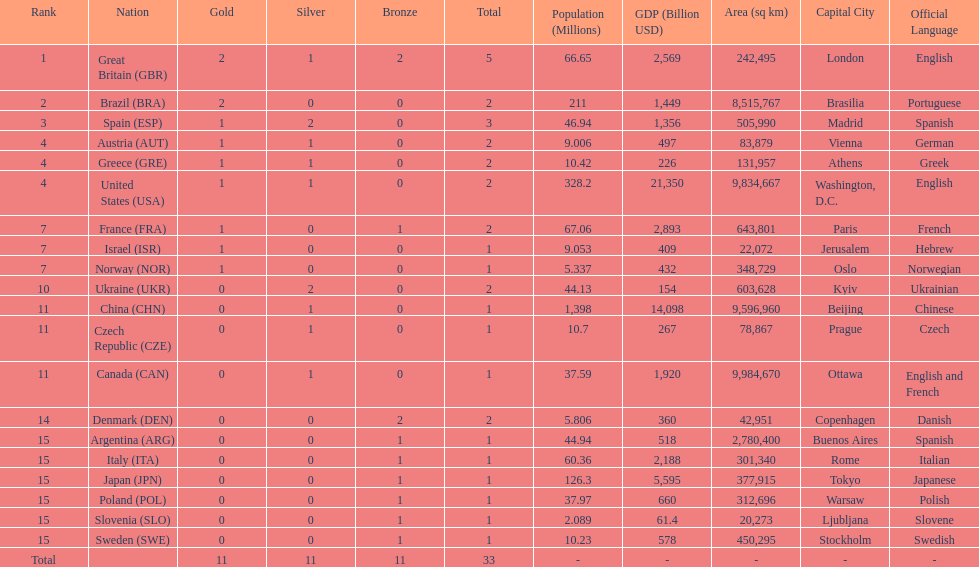What was the total number of medals won by united states? 2. 